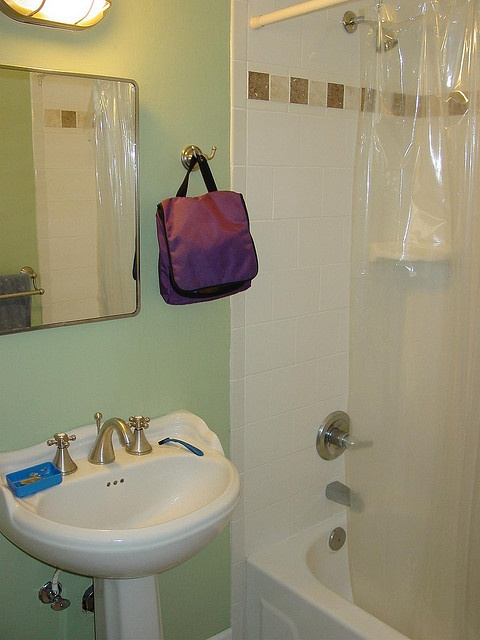Describe the objects in this image and their specific colors. I can see sink in olive, darkgray, gray, and tan tones, handbag in olive, purple, black, and maroon tones, backpack in olive, purple, black, and maroon tones, and toothbrush in olive, blue, black, darkblue, and gray tones in this image. 